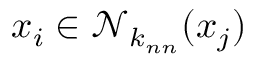<formula> <loc_0><loc_0><loc_500><loc_500>x _ { i } \in \mathcal { N } _ { k _ { n n } } ( x _ { j } )</formula> 